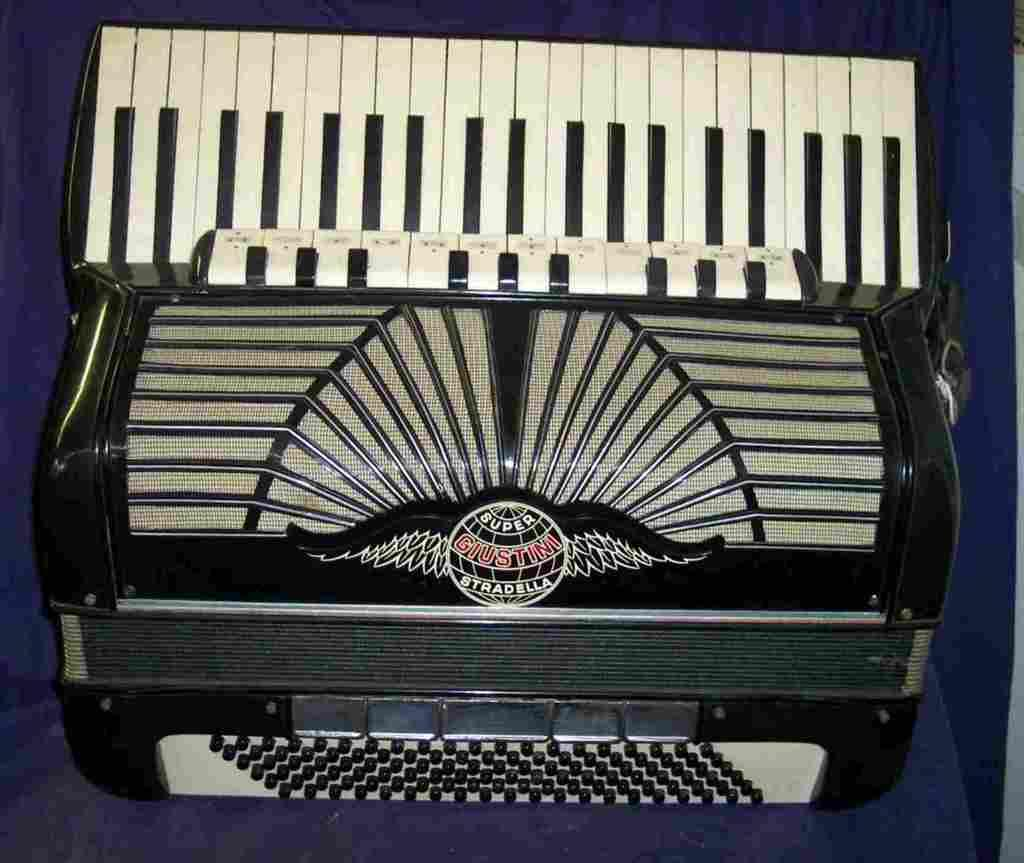What type of musical instrument is featured in the image? The image contains a musical instrument named Hohner Atlantic. Can you describe any distinguishing features of the instrument? There is a logo on the musical instrument. What color is the background of the image? The background of the image is dark blue in color. How many songs can be heard playing from the gun in the image? There is no gun present in the image, and therefore no songs can be heard playing from it. 